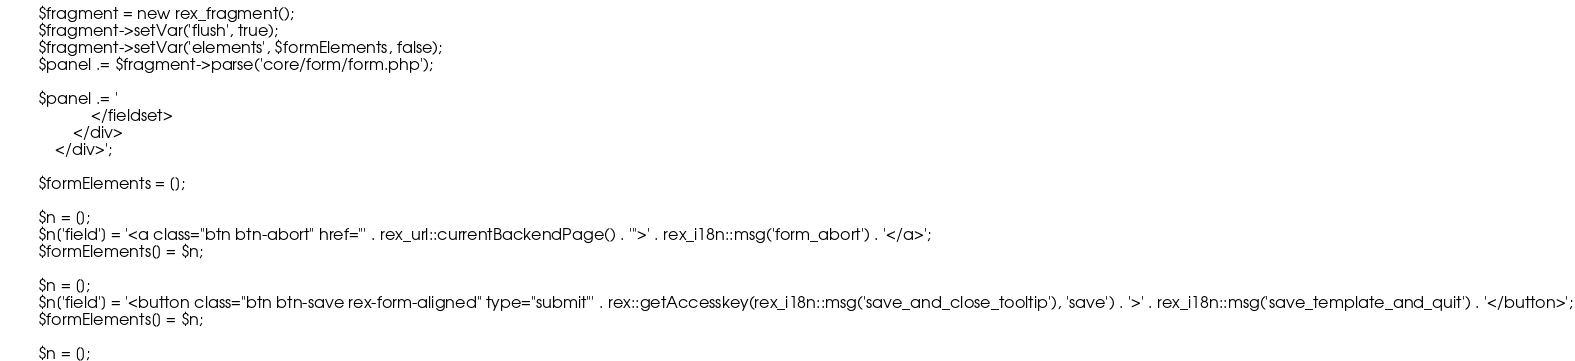<code> <loc_0><loc_0><loc_500><loc_500><_PHP_>        $fragment = new rex_fragment();
        $fragment->setVar('flush', true);
        $fragment->setVar('elements', $formElements, false);
        $panel .= $fragment->parse('core/form/form.php');

        $panel .= '
                    </fieldset>
                </div>
            </div>';

        $formElements = [];

        $n = [];
        $n['field'] = '<a class="btn btn-abort" href="' . rex_url::currentBackendPage() . '">' . rex_i18n::msg('form_abort') . '</a>';
        $formElements[] = $n;

        $n = [];
        $n['field'] = '<button class="btn btn-save rex-form-aligned" type="submit"' . rex::getAccesskey(rex_i18n::msg('save_and_close_tooltip'), 'save') . '>' . rex_i18n::msg('save_template_and_quit') . '</button>';
        $formElements[] = $n;

        $n = [];</code> 